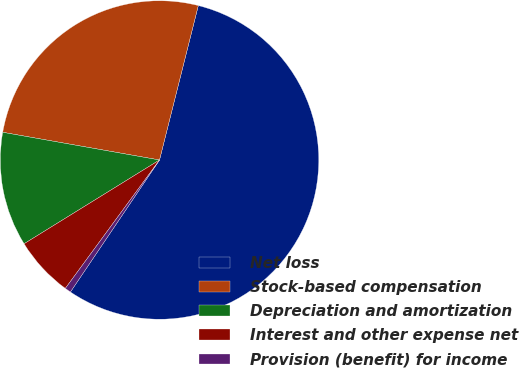<chart> <loc_0><loc_0><loc_500><loc_500><pie_chart><fcel>Net loss<fcel>Stock-based compensation<fcel>Depreciation and amortization<fcel>Interest and other expense net<fcel>Provision (benefit) for income<nl><fcel>55.52%<fcel>26.13%<fcel>11.6%<fcel>6.11%<fcel>0.62%<nl></chart> 